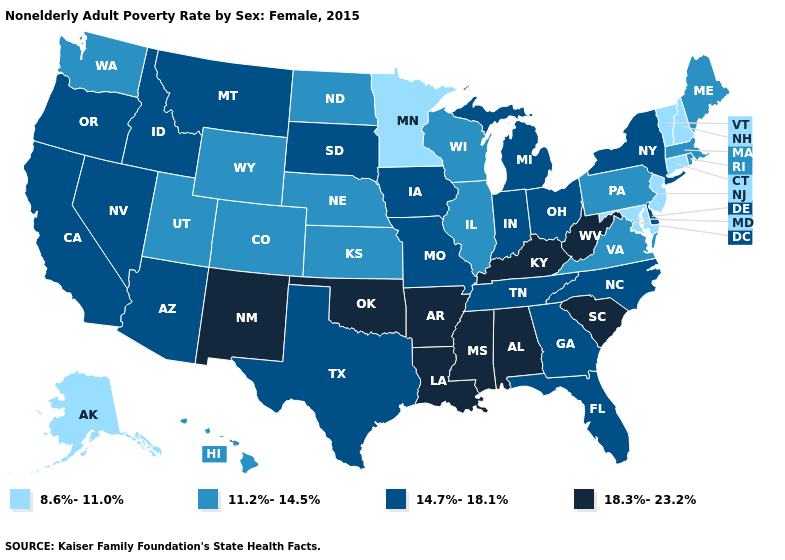How many symbols are there in the legend?
Write a very short answer. 4. Which states hav the highest value in the MidWest?
Give a very brief answer. Indiana, Iowa, Michigan, Missouri, Ohio, South Dakota. Among the states that border Minnesota , does Wisconsin have the highest value?
Keep it brief. No. What is the value of Kansas?
Be succinct. 11.2%-14.5%. Name the states that have a value in the range 14.7%-18.1%?
Quick response, please. Arizona, California, Delaware, Florida, Georgia, Idaho, Indiana, Iowa, Michigan, Missouri, Montana, Nevada, New York, North Carolina, Ohio, Oregon, South Dakota, Tennessee, Texas. What is the highest value in the USA?
Concise answer only. 18.3%-23.2%. What is the highest value in states that border Tennessee?
Concise answer only. 18.3%-23.2%. Which states have the lowest value in the South?
Keep it brief. Maryland. Which states have the lowest value in the USA?
Short answer required. Alaska, Connecticut, Maryland, Minnesota, New Hampshire, New Jersey, Vermont. Is the legend a continuous bar?
Be succinct. No. What is the lowest value in the Northeast?
Short answer required. 8.6%-11.0%. Name the states that have a value in the range 8.6%-11.0%?
Write a very short answer. Alaska, Connecticut, Maryland, Minnesota, New Hampshire, New Jersey, Vermont. Name the states that have a value in the range 18.3%-23.2%?
Quick response, please. Alabama, Arkansas, Kentucky, Louisiana, Mississippi, New Mexico, Oklahoma, South Carolina, West Virginia. What is the value of Indiana?
Be succinct. 14.7%-18.1%. 